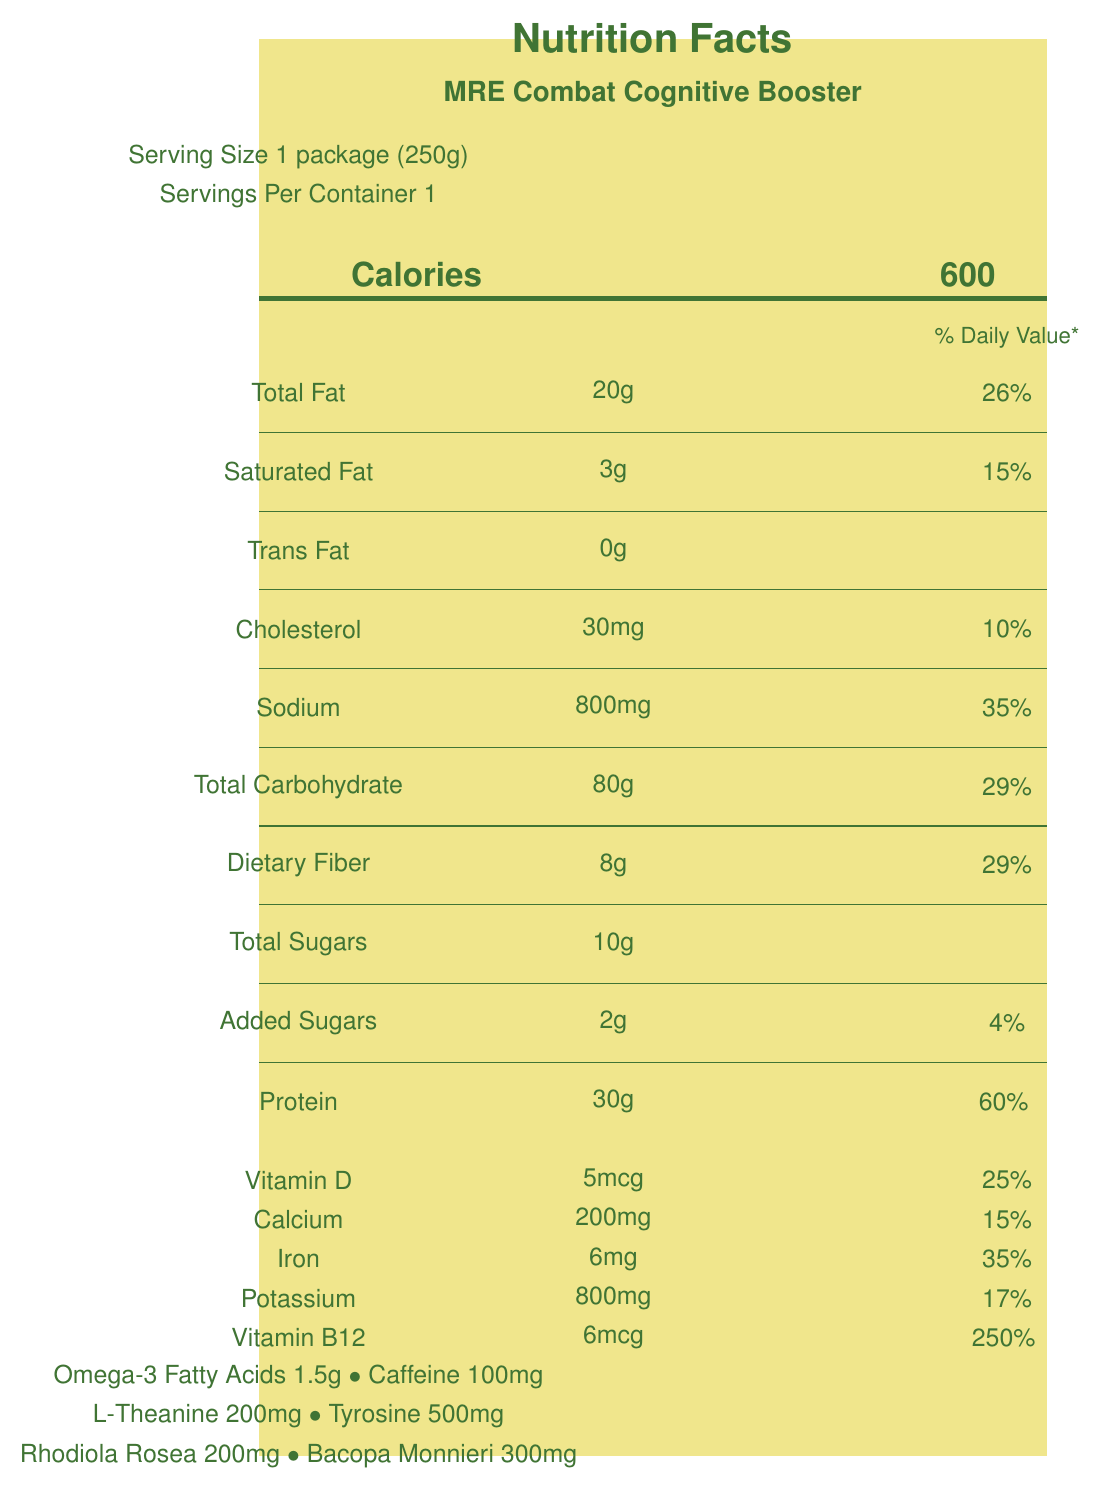what is the serving size of the MRE Combat Cognitive Booster? The label indicates the serving size is "1 package (250g)".
Answer: 1 package (250g) how many calories does one serving of the MRE Combat Cognitive Booster contain? The calorie content per serving is displayed directly under the calorie information as "600".
Answer: 600 what is the total amount of protein per serving? The nutritional table lists "Protein" with an amount of "30g".
Answer: 30g how much sodium is in one serving of this product? The nutritional table specifies "Sodium" at "800mg" per serving.
Answer: 800mg what is the percentage of daily value for vitamin B12 in one serving? The vitamin and mineral table shows "Vitamin B12" with a daily value of "250%".
Answer: 250% which nutrient has the highest daily value percentage per serving? A. Sodium B. Protein C. Iron D. Vitamin B12 The daily value percentage for Vitamin B12 is 250%, which is higher than any other listed nutrient.
Answer: D how many grams of dietary fiber does each serving provide? The nutritional table indicates "Dietary Fiber" with an amount of "8g".
Answer: 8g True or False: This product contains trans fat. The label shows that "Trans Fat" is listed as "0g".
Answer: False what special ingredients are included to enhance cognitive performance? A. Caffeine B. Rhodiola Rosea C. Bacopa Monnieri D. All of the above The additional nutrients section lists Caffeine, Rhodiola Rosea, and Bacopa Monnieri, indicating they are all included for cognitive performance.
Answer: D can the amount of omega-3 fatty acids be determined from this document? The additional nutrients section shows that Omega-3 Fatty Acids are listed with an amount of "1.5g".
Answer: Yes, it is 1.5g describe the main purpose and function of this MRE Combat Cognitive Booster. This summary includes all key points from the additional information section, describing its development for military use, cognitive, physical benefits, and practical features.
Answer: The MRE Combat Cognitive Booster is a meal ready-to-eat developed for Special Operations Forces. It is enhanced with nootropics for cognitive performance and includes balanced macronutrients for sustained energy. It is fortified with vitamins and minerals for immune support, includes electrolytes for hydration in extreme conditions, and is designed to support decision-making under stress. what is the source of the historical context for this product? The visual information from the document does not specify the source beyond mentioning the U.S. Army Research Institute of Environmental Medicine. The detailed source cannot be determined from the given data.
Answer: Not enough information 